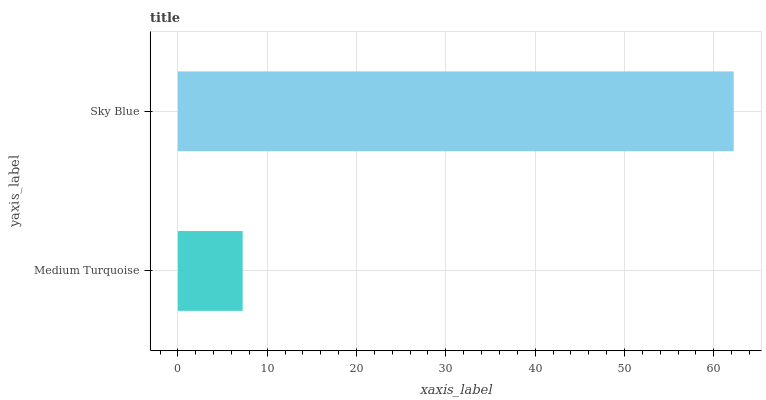Is Medium Turquoise the minimum?
Answer yes or no. Yes. Is Sky Blue the maximum?
Answer yes or no. Yes. Is Sky Blue the minimum?
Answer yes or no. No. Is Sky Blue greater than Medium Turquoise?
Answer yes or no. Yes. Is Medium Turquoise less than Sky Blue?
Answer yes or no. Yes. Is Medium Turquoise greater than Sky Blue?
Answer yes or no. No. Is Sky Blue less than Medium Turquoise?
Answer yes or no. No. Is Sky Blue the high median?
Answer yes or no. Yes. Is Medium Turquoise the low median?
Answer yes or no. Yes. Is Medium Turquoise the high median?
Answer yes or no. No. Is Sky Blue the low median?
Answer yes or no. No. 